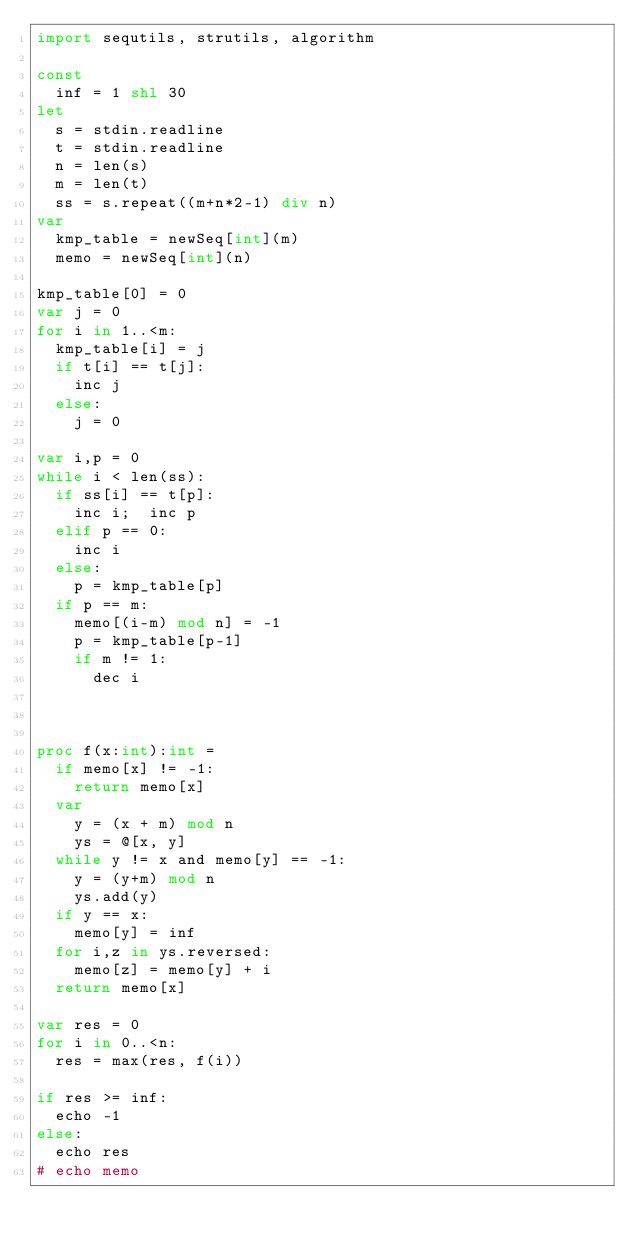Convert code to text. <code><loc_0><loc_0><loc_500><loc_500><_Nim_>import sequtils, strutils, algorithm

const
  inf = 1 shl 30
let
  s = stdin.readline
  t = stdin.readline
  n = len(s)
  m = len(t)
  ss = s.repeat((m+n*2-1) div n)
var
  kmp_table = newSeq[int](m)
  memo = newSeq[int](n)

kmp_table[0] = 0
var j = 0
for i in 1..<m:
  kmp_table[i] = j
  if t[i] == t[j]:
    inc j
  else:
    j = 0

var i,p = 0
while i < len(ss):
  if ss[i] == t[p]:
    inc i;  inc p
  elif p == 0:
    inc i
  else:
    p = kmp_table[p]
  if p == m:
    memo[(i-m) mod n] = -1
    p = kmp_table[p-1]
    if m != 1:
      dec i



proc f(x:int):int =
  if memo[x] != -1:
    return memo[x]
  var
    y = (x + m) mod n
    ys = @[x, y]
  while y != x and memo[y] == -1:
    y = (y+m) mod n
    ys.add(y)
  if y == x:
    memo[y] = inf
  for i,z in ys.reversed:
    memo[z] = memo[y] + i
  return memo[x]
  
var res = 0
for i in 0..<n:
  res = max(res, f(i))

if res >= inf:
  echo -1
else:
  echo res
# echo memo
</code> 